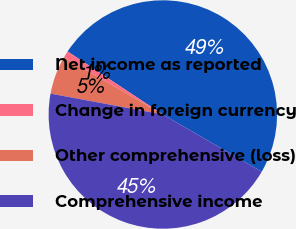<chart> <loc_0><loc_0><loc_500><loc_500><pie_chart><fcel>Net income as reported<fcel>Change in foreign currency<fcel>Other comprehensive (loss)<fcel>Comprehensive income<nl><fcel>49.04%<fcel>0.96%<fcel>5.42%<fcel>44.58%<nl></chart> 